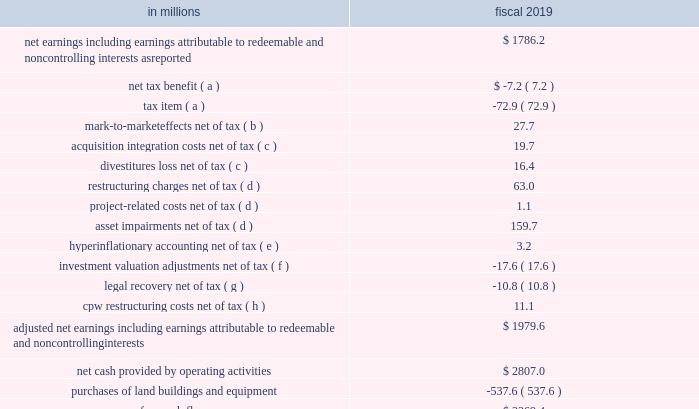Free cash flow conversion rate we believe this measure provides useful information to investors because it is important for assessing our efficiency in converting earnings to cash and returning cash to shareholders .
The calculation of free cash flow conversion rate and net cash provided by operating activities conversion rate , its equivalent gaap measure , follows: .
( a ) see note 14 to the consolidated financial statements in item 8 of this report .
( b ) see note 7 to the consolidated financial statements in item 8 of this report .
( c ) see note 3 to the consolidated financial statements in item 8 of this report .
( d ) see note 4 to the consolidated financial statements in item 8 of this report .
( e ) impact of hyperinflationary accounting for our argentina subsidiary , which was sold in the third quarter of fiscal 2019 .
( f ) valuation gains on certain corporate investments .
( g ) legal recovery related to our yoplait sas subsidiary .
( h ) the cpw restructuring charges are related to initiatives designed to improve profitability and growth that were approved in fiscal 2018 and 2019 .
See our reconciliation below of the effective income tax rate as reported to the adjusted effective income tax rate for the tax impact of each item affecting comparability. .
In 2019 what was the percent of the net earnings to the net cash provided by operating activities? 
Computations: (1786.2 / 2807.0)
Answer: 0.63634. 